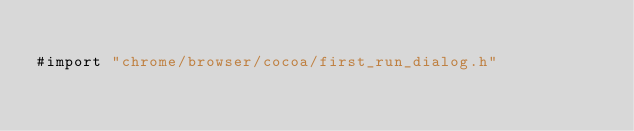Convert code to text. <code><loc_0><loc_0><loc_500><loc_500><_ObjectiveC_>
#import "chrome/browser/cocoa/first_run_dialog.h"
</code> 